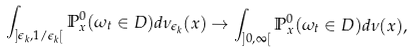Convert formula to latex. <formula><loc_0><loc_0><loc_500><loc_500>\int _ { ] \epsilon _ { k } , 1 / \epsilon _ { k } [ } { \mathbb { P } ^ { 0 } _ { x } ( \omega _ { t } \in D ) d \nu _ { \epsilon _ { k } } ( x ) } \rightarrow \int _ { ] 0 , \infty [ } { \mathbb { P } ^ { 0 } _ { x } ( \omega _ { t } \in D ) d \nu ( x ) } ,</formula> 